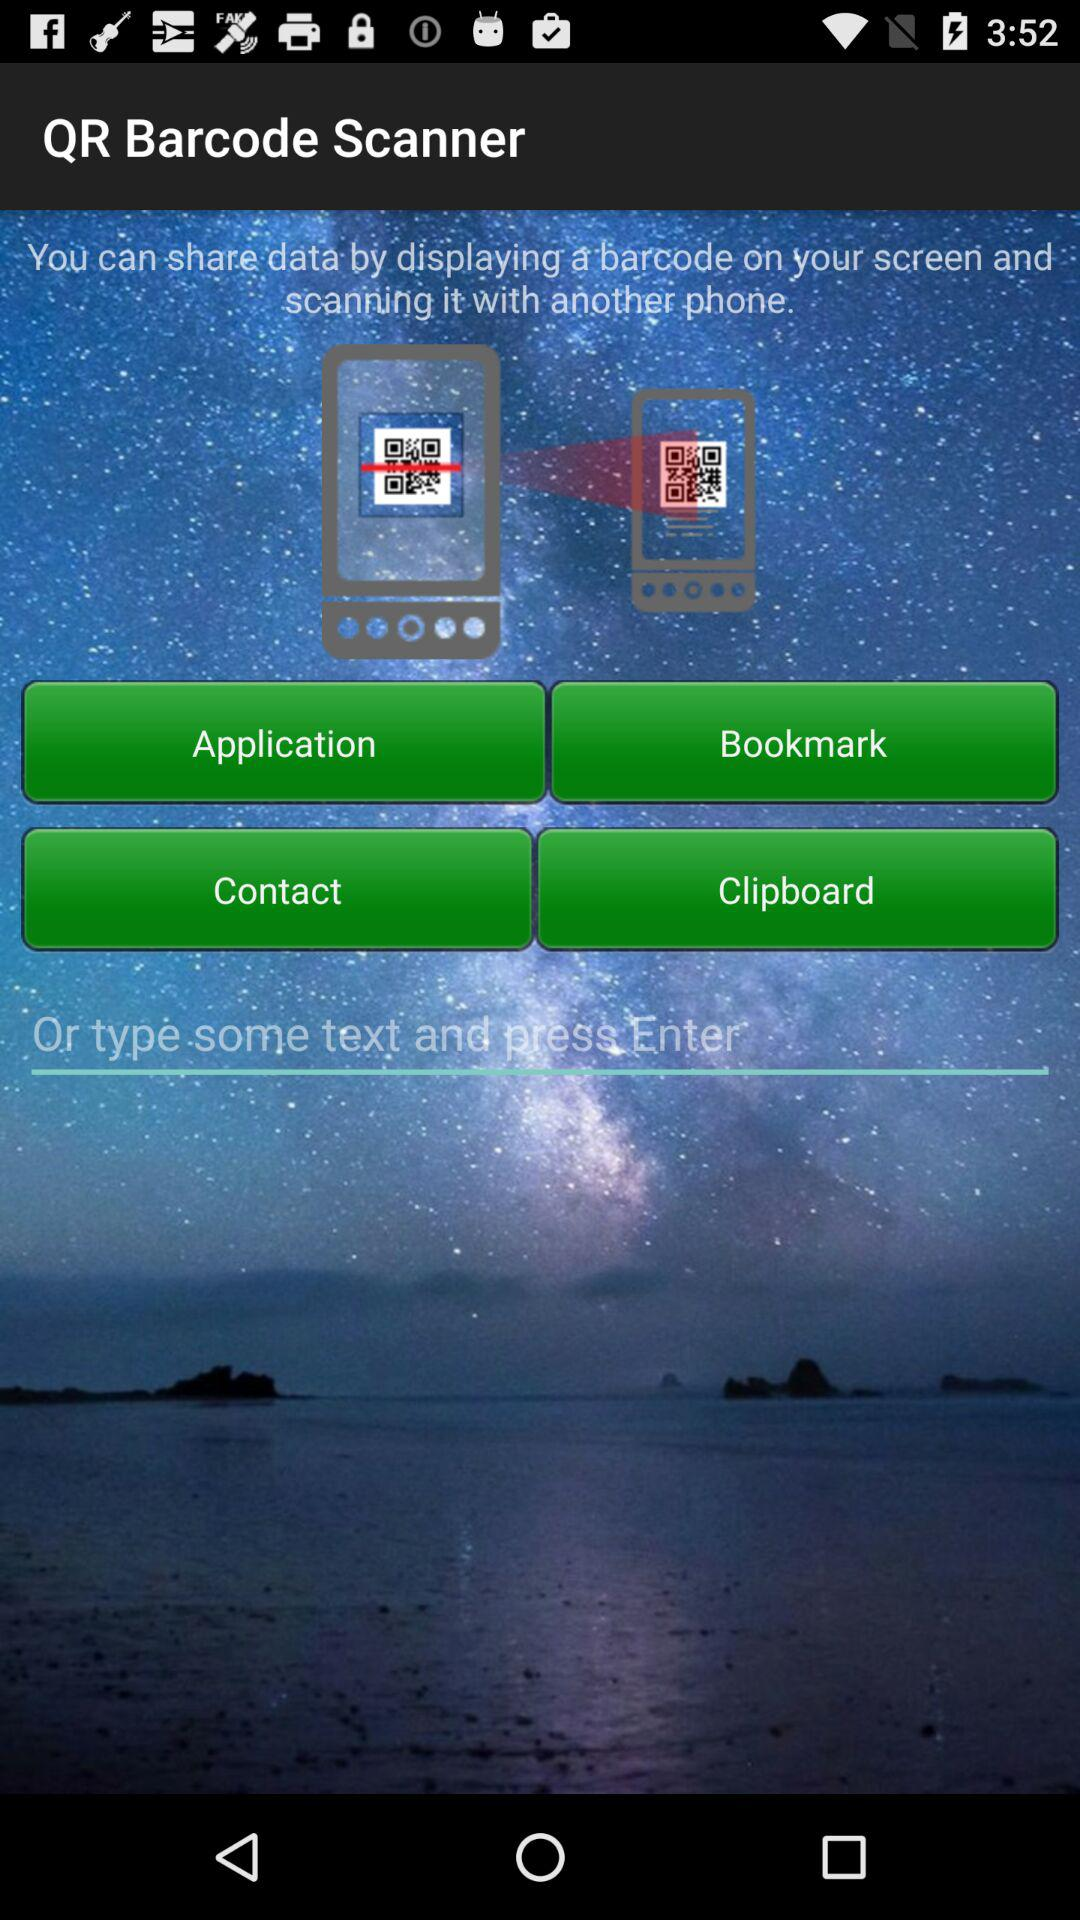Which option is selected?
When the provided information is insufficient, respond with <no answer>. <no answer> 